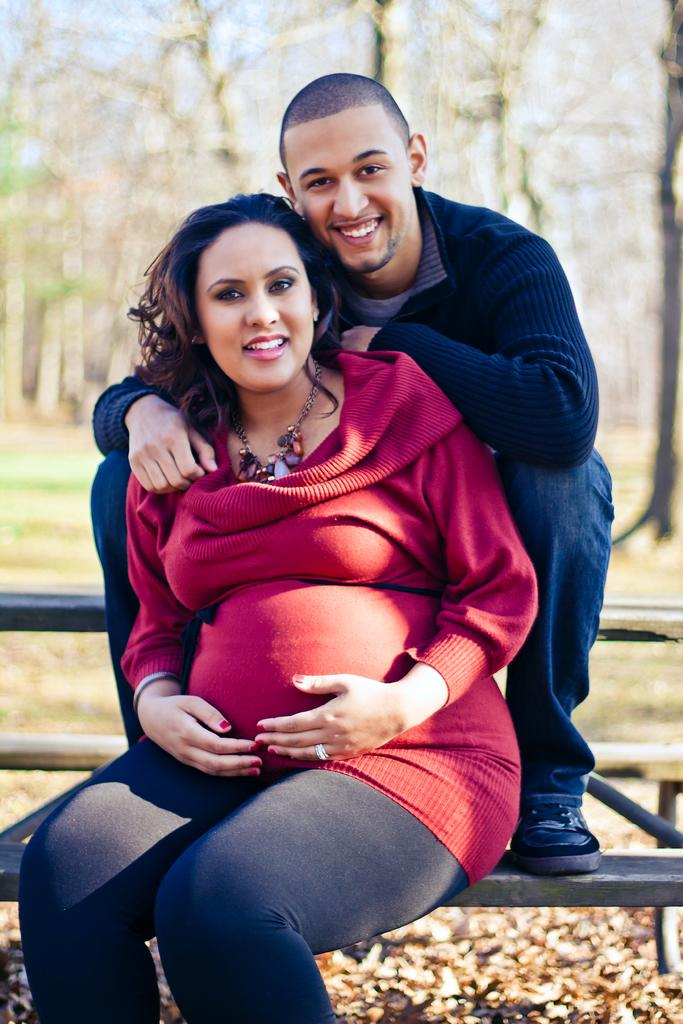Who can be seen in the image? There is a lady and a man in the image. What are the lady and the man doing in the image? Both the lady and the man are sitting on a bench. What can be seen in the background of the image? There are trees in the background of the image. How is the background of the image depicted? The background of the image is blurred. What type of veil is the lady wearing in the image? There is no veil present in the image; the lady is not wearing any head covering. How does the man look at the lady in the image? The image does not show the man looking at the lady, so it cannot be determined from the image. 